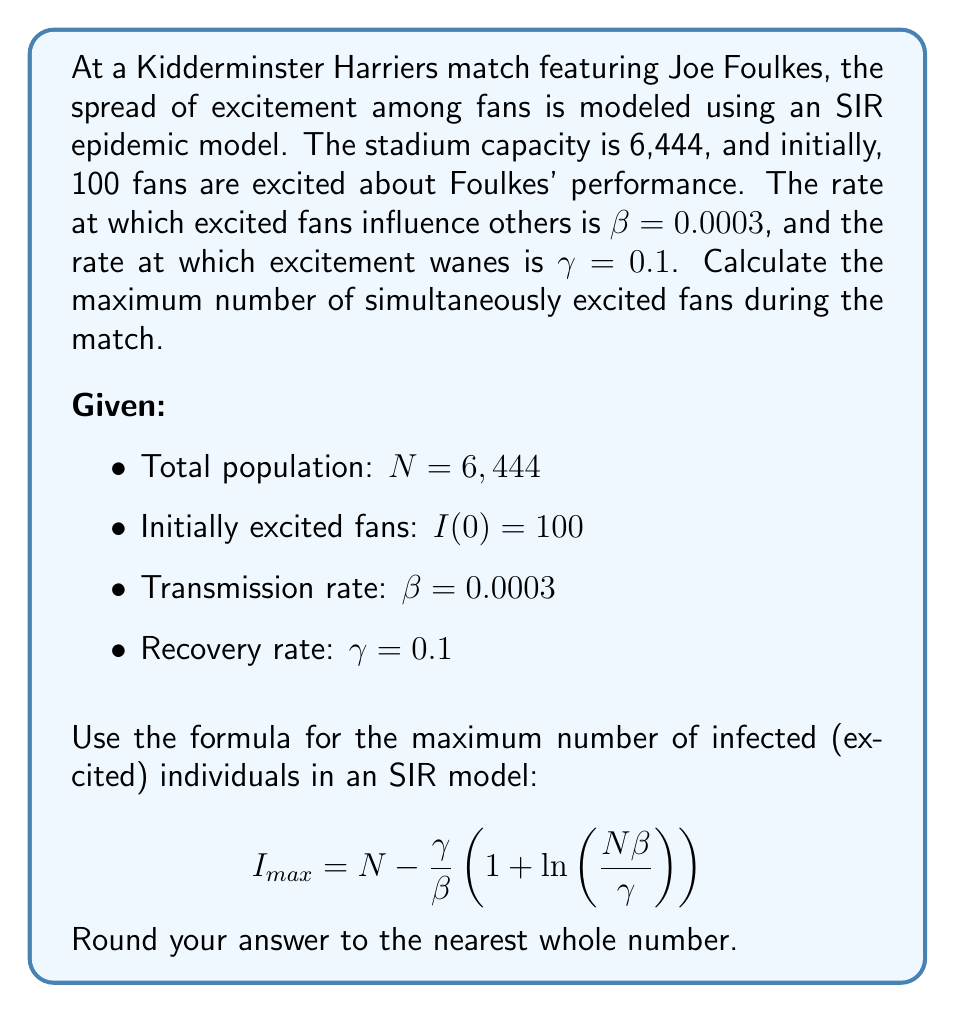Give your solution to this math problem. To solve this problem, we'll follow these steps:

1. Identify the given parameters:
   N = 6,444 (total population)
   β = 0.0003 (transmission rate)
   γ = 0.1 (recovery rate)

2. Substitute these values into the formula for I_max:

   $$I_{max} = N - \frac{\gamma}{\beta}\left(1 + \ln\left(\frac{N\beta}{\gamma}\right)\right)$$

3. Calculate the expression inside the logarithm:
   $$\frac{N\beta}{\gamma} = \frac{6,444 \times 0.0003}{0.1} = 19.332$$

4. Calculate the logarithm:
   $$\ln(19.332) \approx 2.9618$$

5. Solve the expression inside the parentheses:
   $$1 + 2.9618 = 3.9618$$

6. Calculate $\frac{\gamma}{\beta}$:
   $$\frac{\gamma}{\beta} = \frac{0.1}{0.0003} = 333.3333$$

7. Multiply the results from steps 5 and 6:
   $$333.3333 \times 3.9618 = 1,320.5999$$

8. Subtract this value from N:
   $$6,444 - 1,320.5999 = 5,123.4001$$

9. Round to the nearest whole number:
   $$5,123$$

Therefore, the maximum number of simultaneously excited fans during the match is approximately 5,123.
Answer: 5,123 fans 